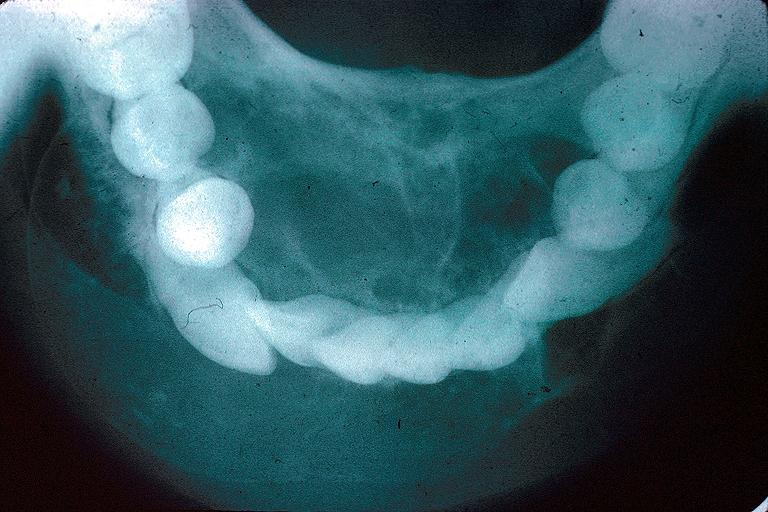where is this?
Answer the question using a single word or phrase. Oral 